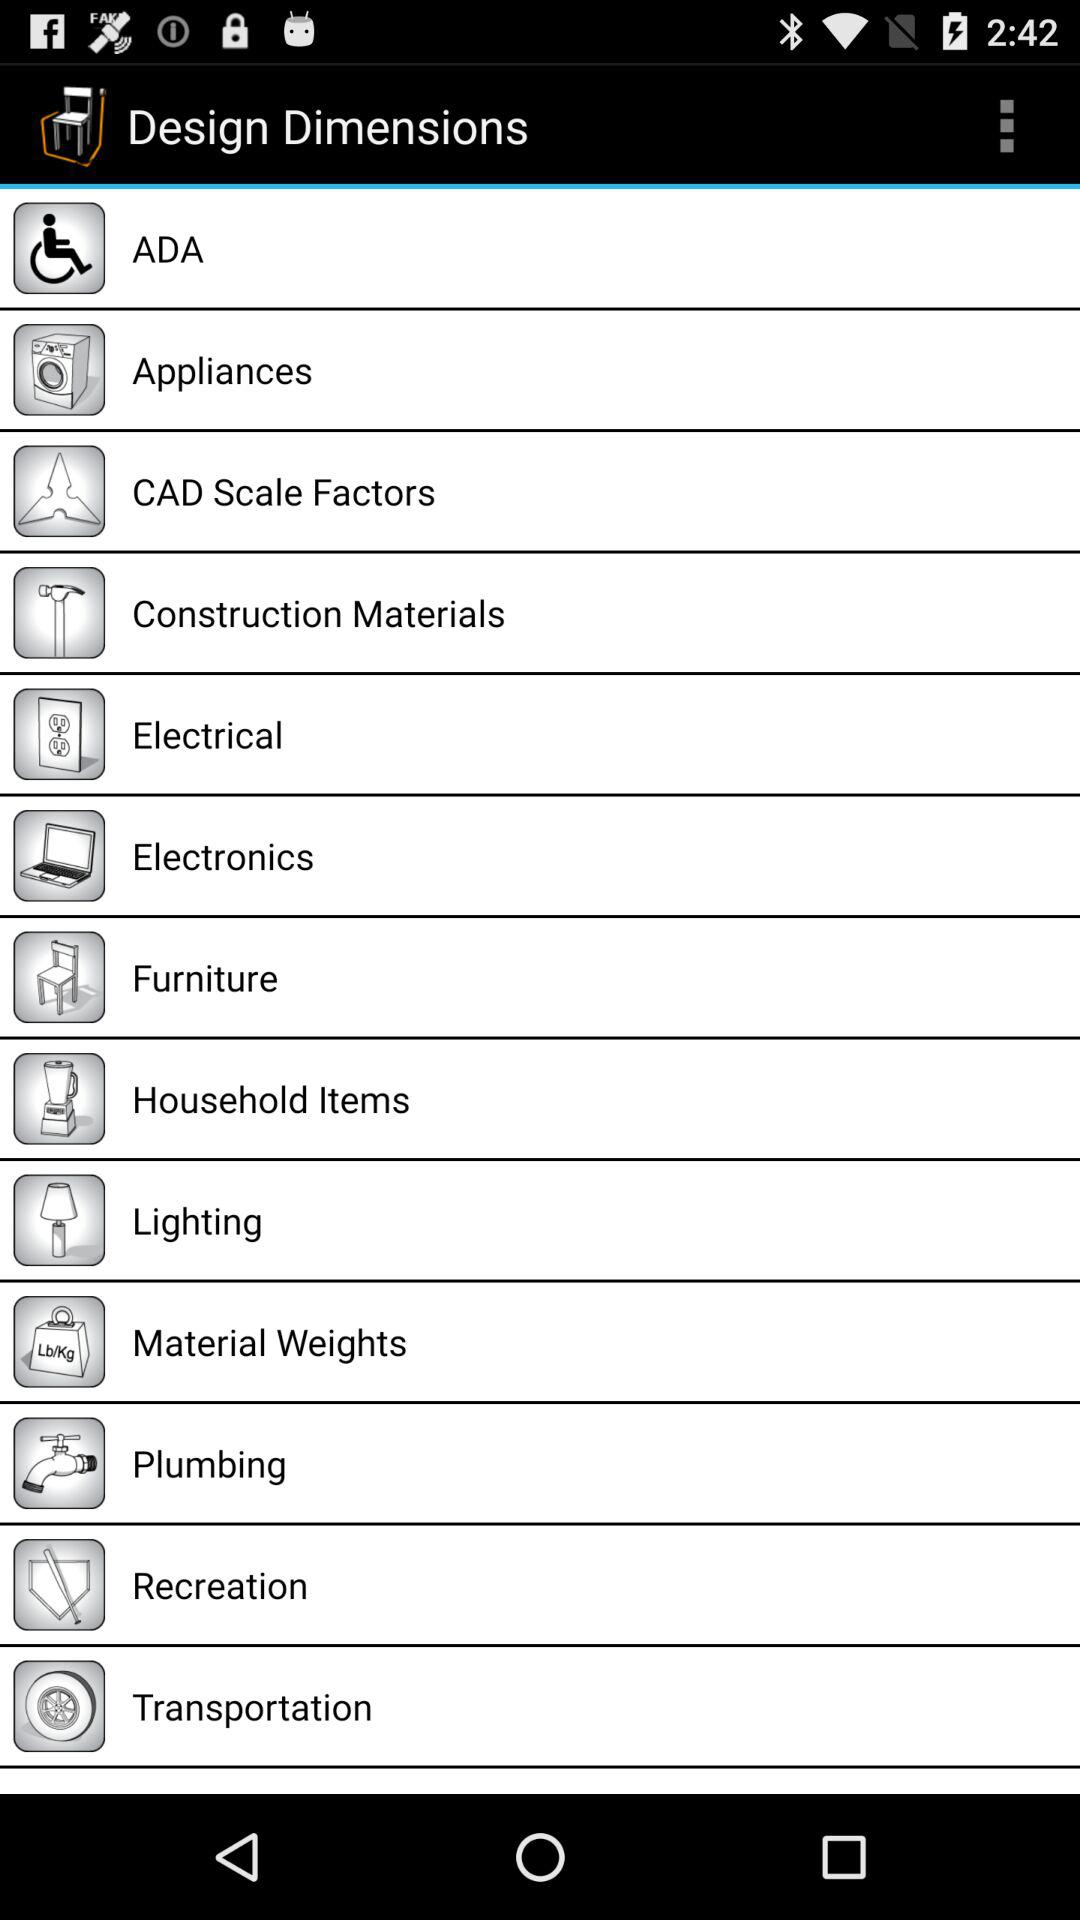What is the application name? The application name is "Design Dimensions". 